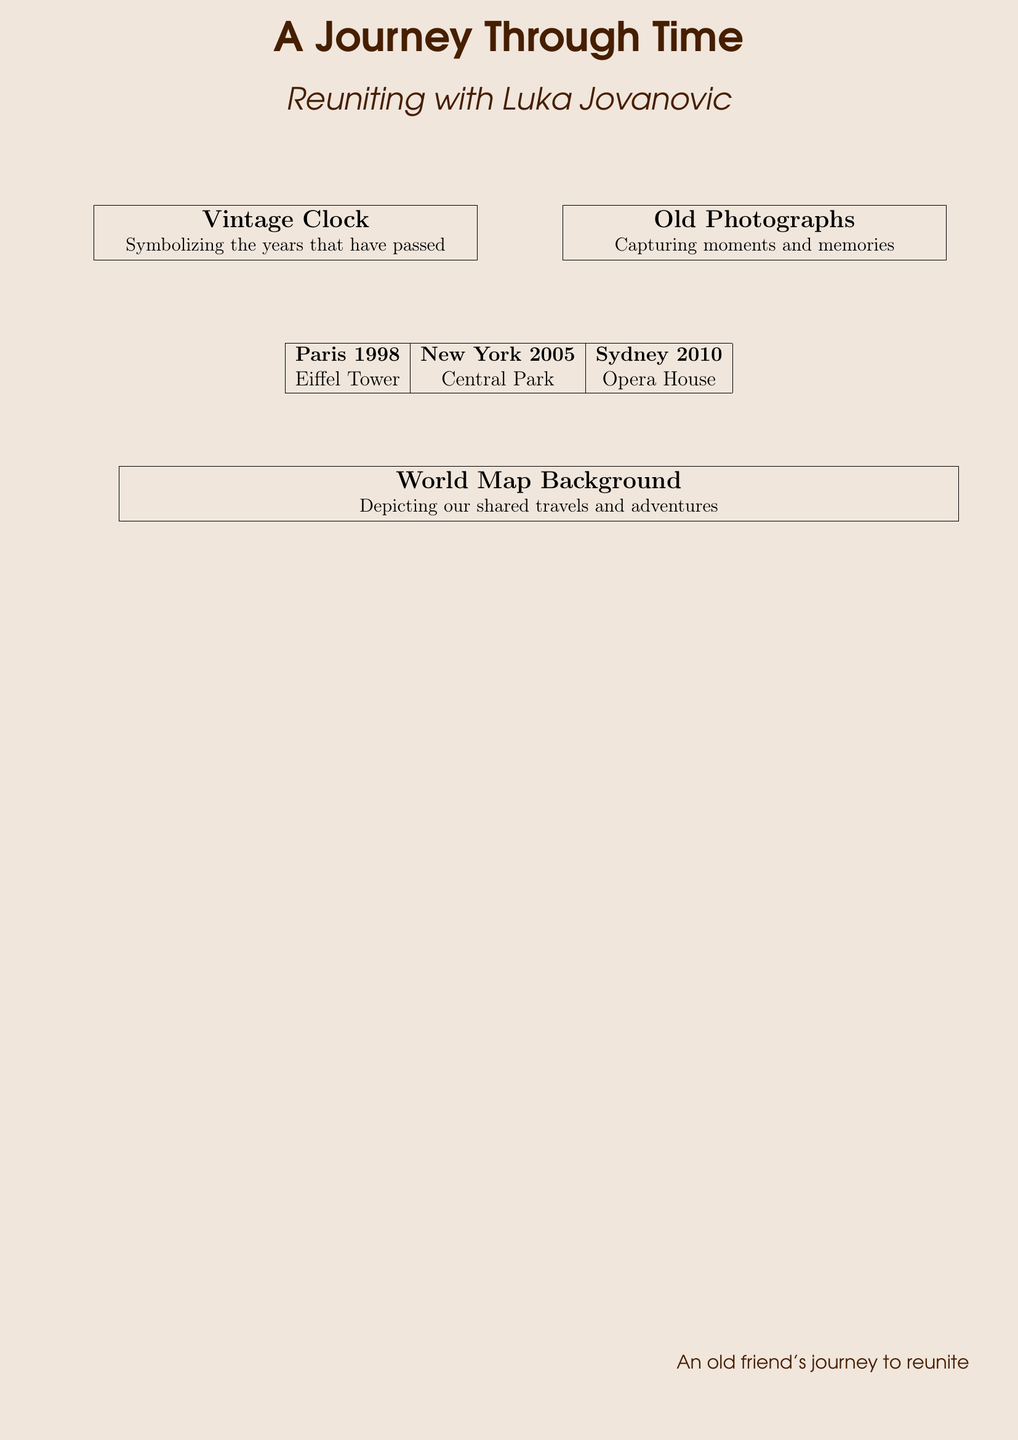What is the title of the book? The title is prominently displayed at the top of the document.
Answer: A Journey Through Time Who is the author of this book? The author's name is found in the subtitle section of the cover.
Answer: Luka Jovanovic What year is associated with Paris on the cover? The year is noted in the table listing locations and dates.
Answer: 1998 What iconic structure is represented for New York? The document lists the landmarks associated with each city.
Answer: Central Park What is the color theme of the book cover? The document describes colors used for text and background.
Answer: Vintage What does the vintage clock symbolize? The text accompanying the clock illustration explains its significance.
Answer: The years that have passed What type of images are featured alongside the clock? The cover includes specific imagery described in the sections.
Answer: Old Photographs Which city is featured in the year 2010? The corresponding location is mentioned in the table.
Answer: Sydney What does the world map background represent? The explanation near the world map highlights its purpose in the design.
Answer: Shared travels and adventures 